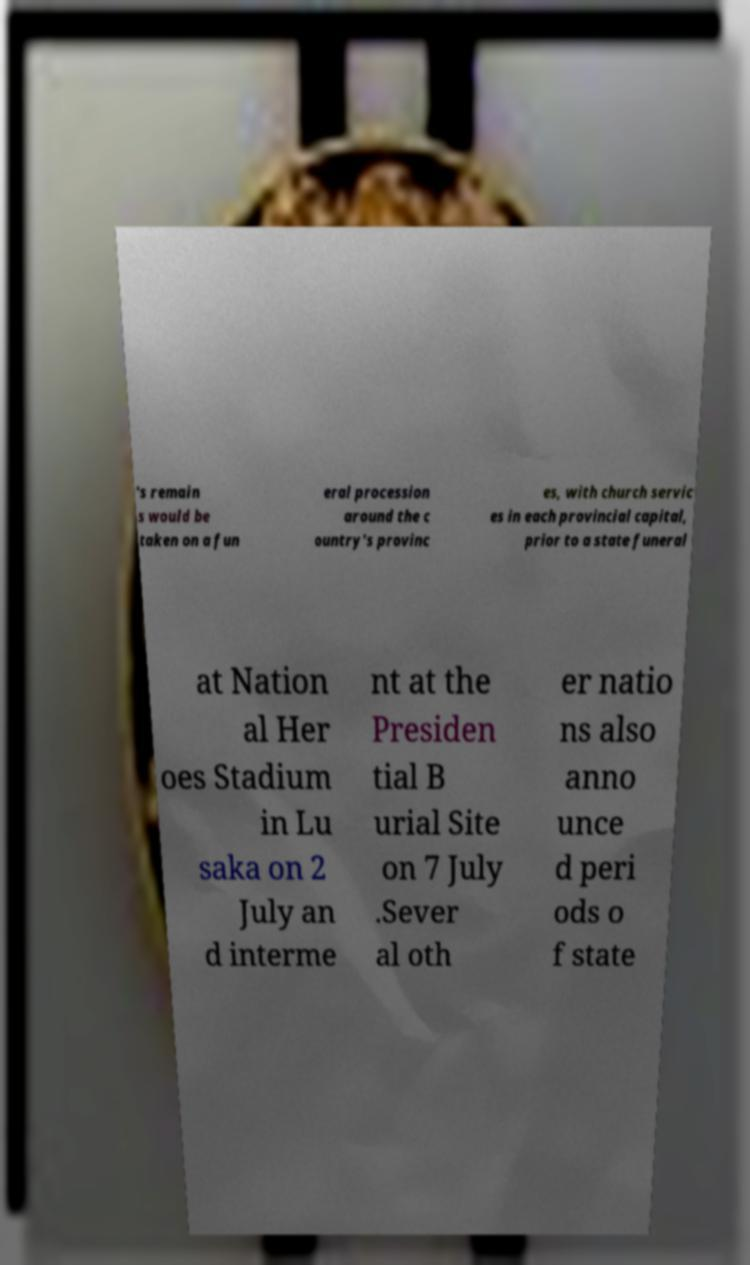Could you extract and type out the text from this image? 's remain s would be taken on a fun eral procession around the c ountry's provinc es, with church servic es in each provincial capital, prior to a state funeral at Nation al Her oes Stadium in Lu saka on 2 July an d interme nt at the Presiden tial B urial Site on 7 July .Sever al oth er natio ns also anno unce d peri ods o f state 